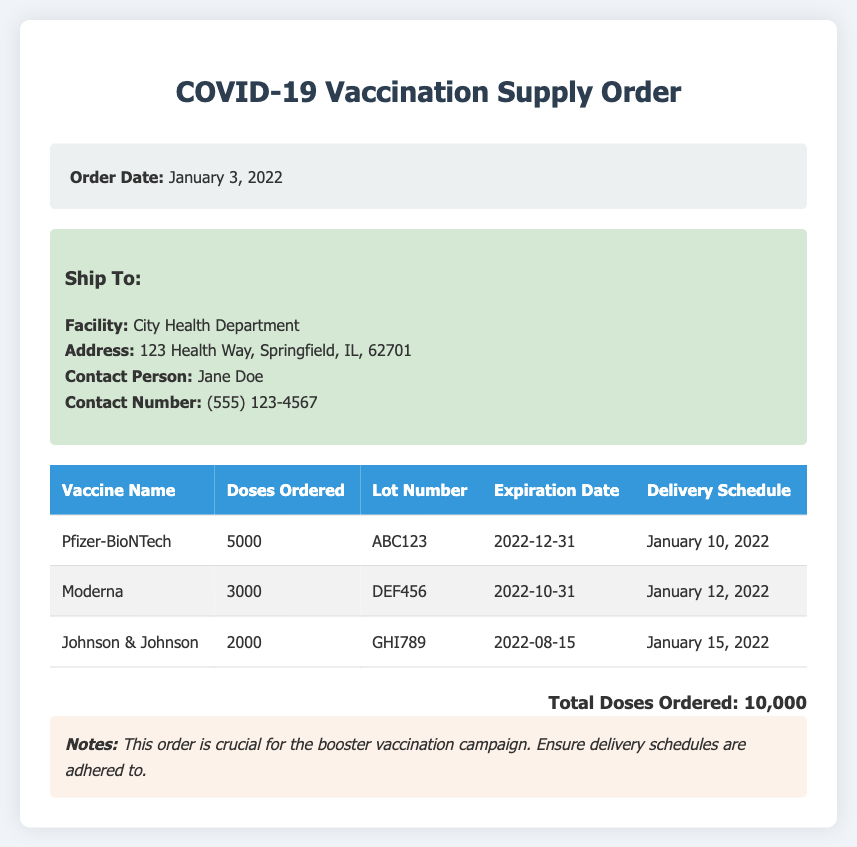What is the order date? The order date is specified in the order information section of the document.
Answer: January 3, 2022 How many doses of Moderna were ordered? The table lists the doses ordered for each vaccine, which is relevant for understanding vaccine supply needs.
Answer: 3000 What is the lot number for the Pfizer-BioNTech vaccine? The lot number for each vaccine is provided in the table and is essential for tracking and safety.
Answer: ABC123 What is the expiration date of the Johnson & Johnson vaccine? The expiration date ensures awareness of vaccine viability and aids in vaccination planning.
Answer: 2022-08-15 When is the delivery schedule for Moderna? The delivery schedule indicates when each type of vaccine is expected to arrive, which is important for planning vaccinations.
Answer: January 12, 2022 Which facility is the shipment addressed to? This information is important for identifying where the vaccines are being sent.
Answer: City Health Department How many total doses were ordered? Understanding the total ordered is essential for evaluating the adequacy of the supply for vaccination efforts.
Answer: 10,000 What is noted about the importance of the order? The notes highlight the significance of the order, offering insight into the document's context and urgency.
Answer: Crucial for the booster vaccination campaign 